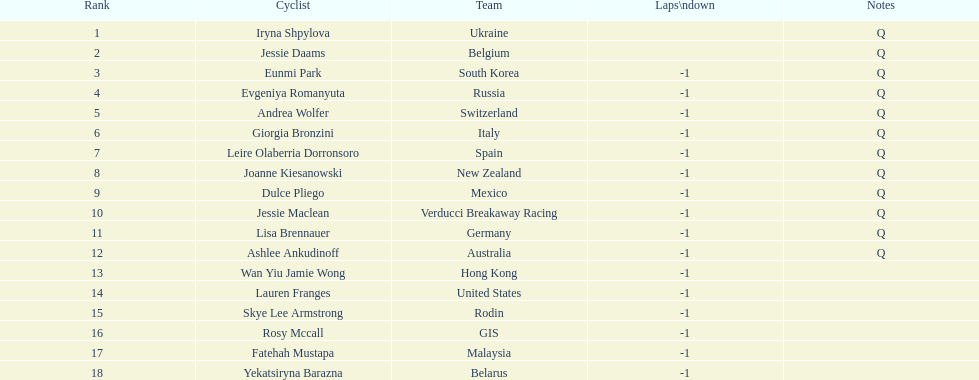Who was the contender that ended up surpassing jessie maclean? Dulce Pliego. 